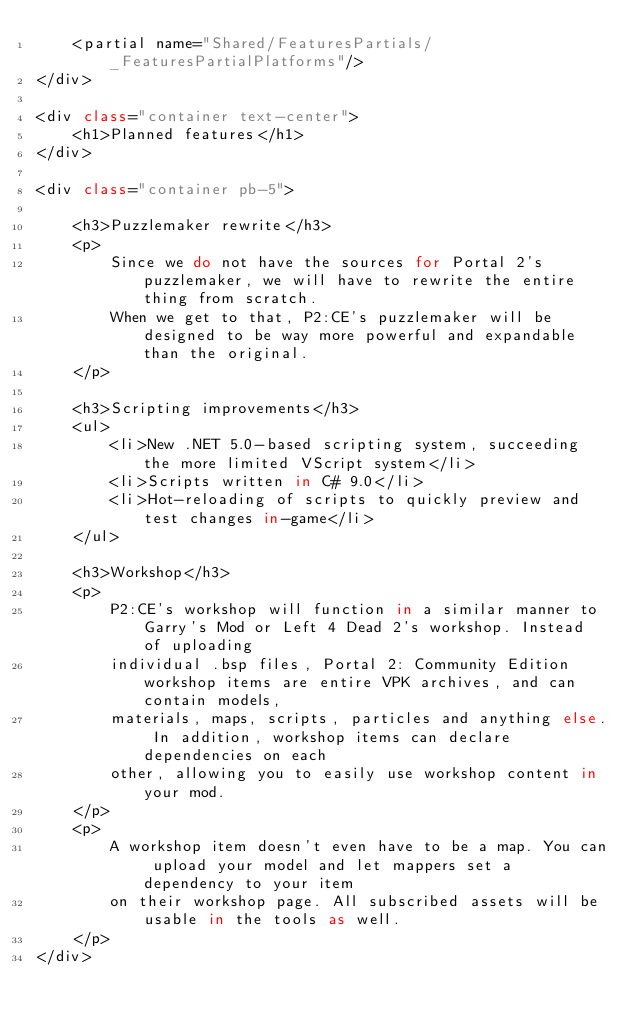Convert code to text. <code><loc_0><loc_0><loc_500><loc_500><_C#_>    <partial name="Shared/FeaturesPartials/_FeaturesPartialPlatforms"/>
</div>

<div class="container text-center">
    <h1>Planned features</h1>
</div>

<div class="container pb-5">
    
    <h3>Puzzlemaker rewrite</h3>
    <p>
        Since we do not have the sources for Portal 2's puzzlemaker, we will have to rewrite the entire thing from scratch.
        When we get to that, P2:CE's puzzlemaker will be designed to be way more powerful and expandable than the original.
    </p>
    
    <h3>Scripting improvements</h3>
    <ul>
        <li>New .NET 5.0-based scripting system, succeeding the more limited VScript system</li>
        <li>Scripts written in C# 9.0</li>
        <li>Hot-reloading of scripts to quickly preview and test changes in-game</li>
    </ul>
    
    <h3>Workshop</h3>
    <p>
        P2:CE's workshop will function in a similar manner to Garry's Mod or Left 4 Dead 2's workshop. Instead of uploading
        individual .bsp files, Portal 2: Community Edition workshop items are entire VPK archives, and can contain models,
        materials, maps, scripts, particles and anything else. In addition, workshop items can declare dependencies on each
        other, allowing you to easily use workshop content in your mod.
    </p>
    <p>
        A workshop item doesn't even have to be a map. You can upload your model and let mappers set a dependency to your item
        on their workshop page. All subscribed assets will be usable in the tools as well. 
    </p>
</div></code> 